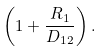<formula> <loc_0><loc_0><loc_500><loc_500>\left ( { 1 + \frac { R _ { 1 } } { D _ { 1 2 } } } \right ) .</formula> 